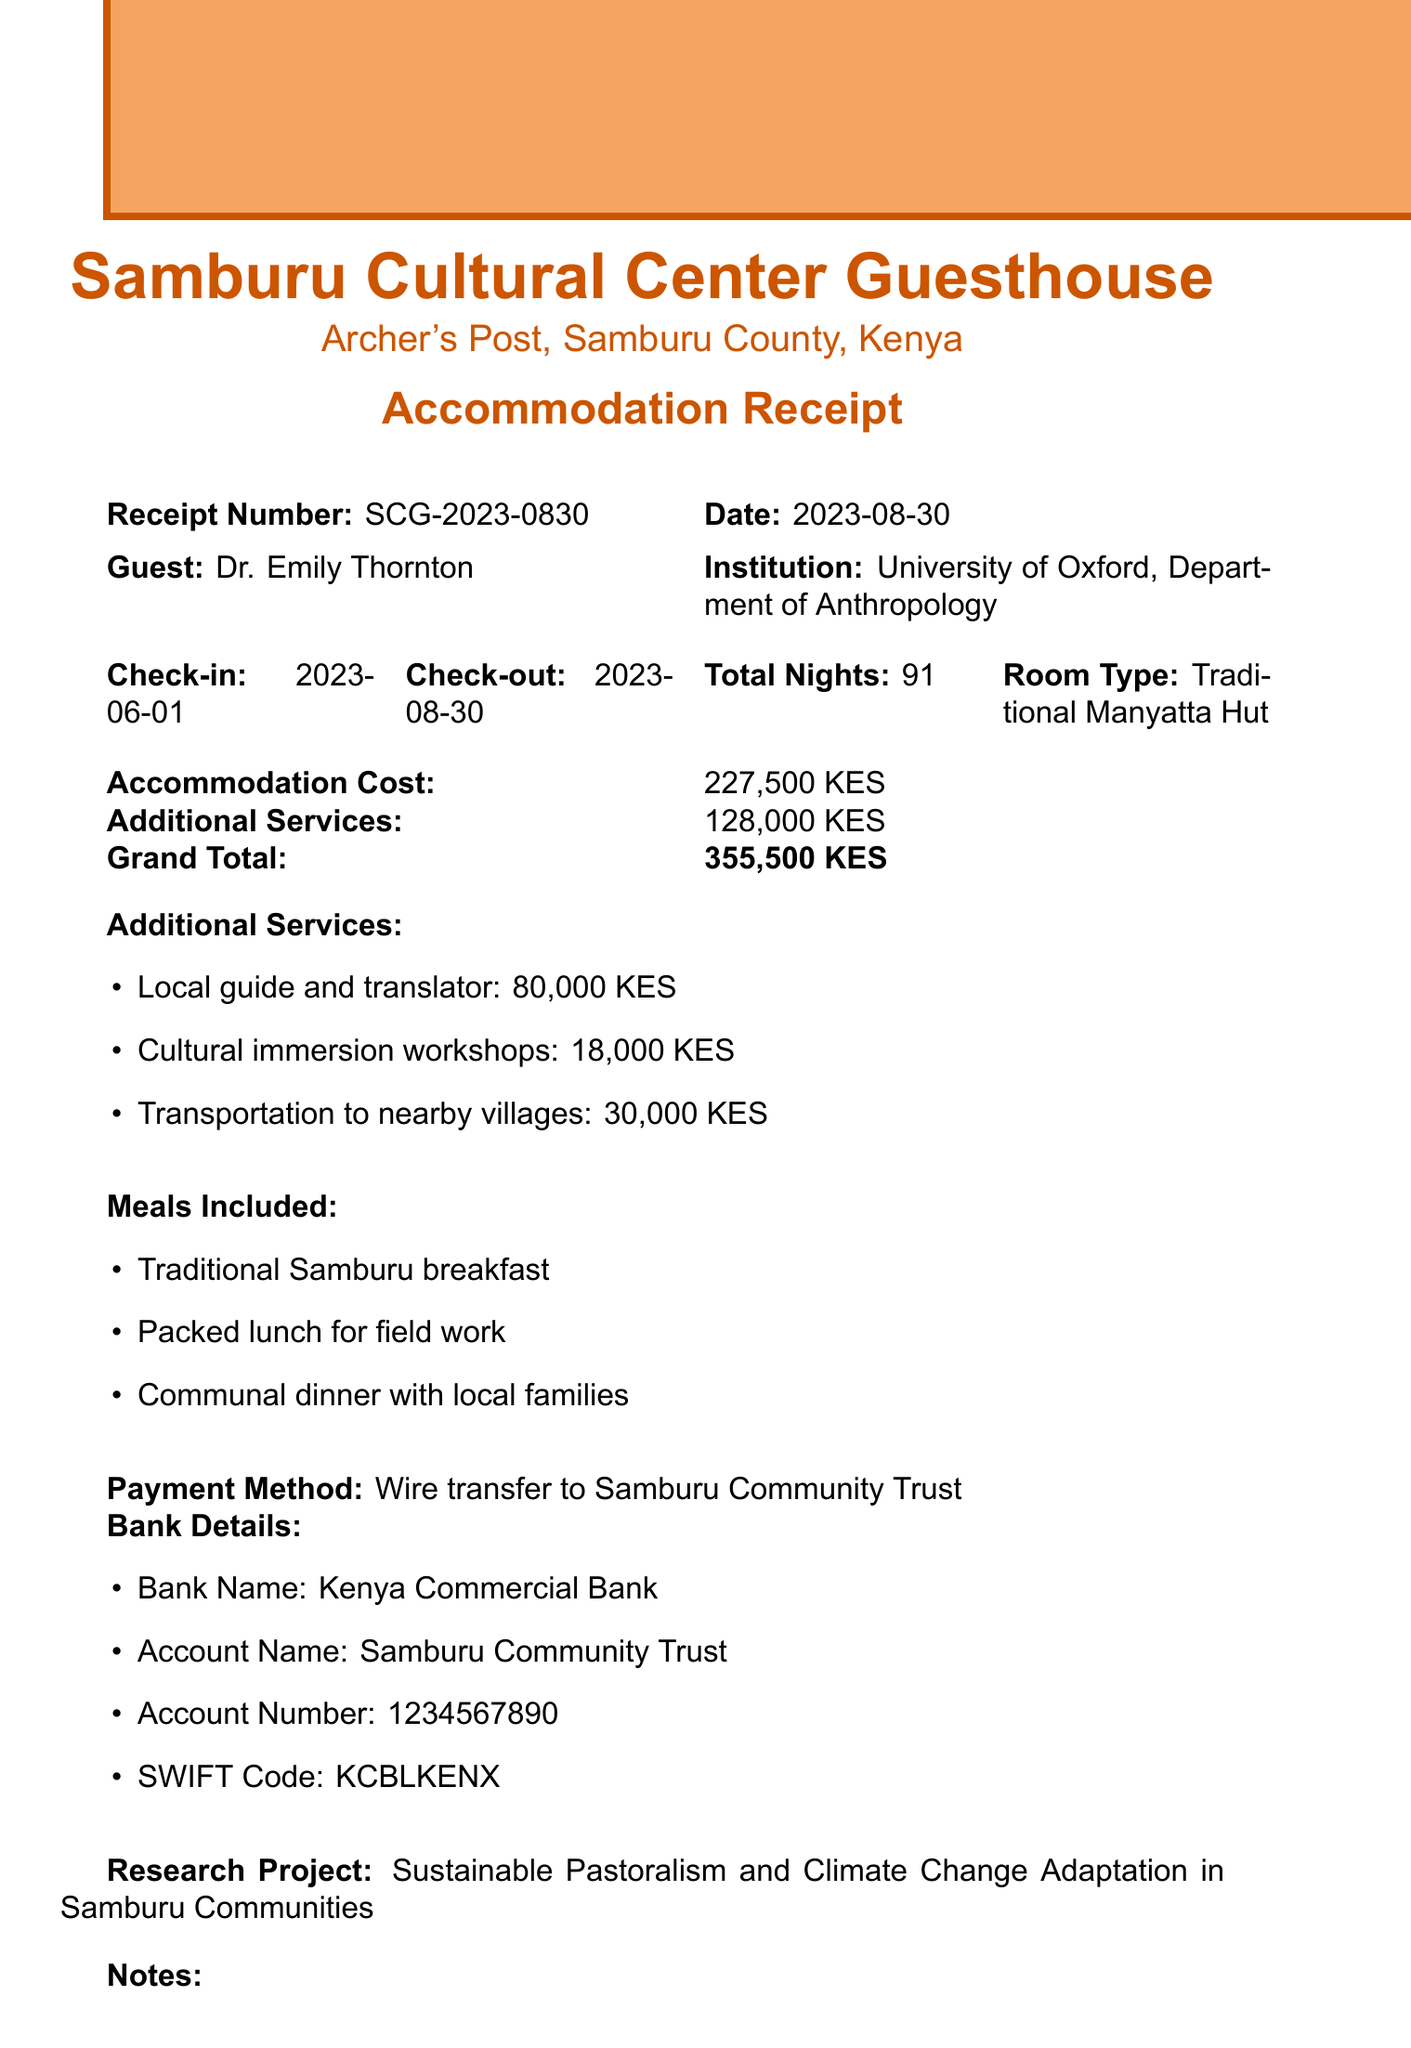What is the guesthouse name? The guesthouse name is specified at the top of the document.
Answer: Samburu Cultural Center Guesthouse What is the total accommodation cost? The total accommodation cost is explicitly stated in the document.
Answer: 227,500 KES Who is the guest? The name of the guest is listed in the document.
Answer: Dr. Emily Thornton What is the check-out date? The check-out date is clearly mentioned in the document.
Answer: 2023-08-30 What is the total number of nights stayed? This information is provided in the details of the stay.
Answer: 91 What is the total cost for additional services? The total additional services cost is provided in the document.
Answer: 128,000 KES What payment method was used? The payment method is clearly indicated in the receipt.
Answer: Wire transfer to Samburu Community Trust Which meals are included in the accommodation? A list of meals included is specified in the document.
Answer: Traditional Samburu breakfast, Packed lunch for field work, Communal dinner with local families What is the research project title? The title of the research project is mentioned under research details.
Answer: Sustainable Pastoralism and Climate Change Adaptation in Samburu Communities 